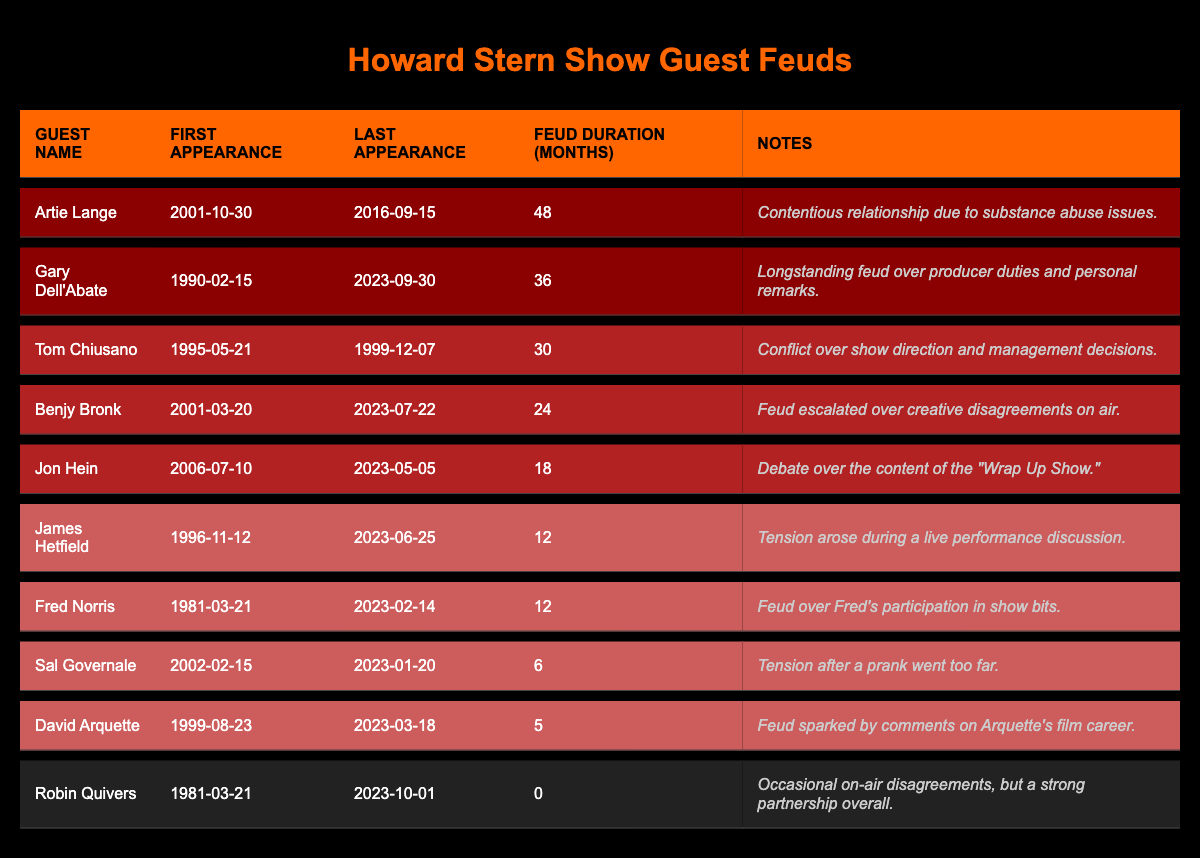What is the feud duration for Artie Lange? The table lists the feud duration of Artie Lange as 48 months.
Answer: 48 months Who had the longest feud duration on the table? By comparing the feud durations, Artie Lange has the longest feud duration of 48 months.
Answer: Artie Lange How many months did Gary Dell'Abate feud last? The table states that Gary Dell'Abate’s feud duration is 36 months.
Answer: 36 months Which guest had a feud duration of 0 months? The table indicates that Robin Quivers has a feud duration of 0 months, signifying no significant feud.
Answer: Robin Quivers Which two guests had feud durations of 12 months? The table shows that James Hetfield and Fred Norris both have a feud duration of 12 months each.
Answer: James Hetfield and Fred Norris What is the average feud duration of guests with medium feud durations on the table? The medium feud durations for Benjy Bronk (24), Jon Hein (18), and Tom Chiusano (30) can be averaged: (24 + 18 + 30) / 3 = 24.
Answer: 24 months Is it true that David Arquette had a longer feud than Sal Governale? David Arquette had a feud duration of 5 months and Sal Governale for 6 months, so the statement is false.
Answer: No Which guest has the shortest feud duration and what is it? The table shows David Arquette having the shortest feud duration of 5 months.
Answer: 5 months What is the total feud duration for all guests listed? Adding all the feud durations: 48 + 36 + 24 + 12 + 30 + 18 + 12 + 6 + 5 + 0 = 191 months.
Answer: 191 months How many guests had feuds lasting longer than 24 months? The guests with feuds longer than 24 months are Artie Lange (48), Gary Dell'Abate (36), and Benjy Bronk (24). That makes three guests.
Answer: 3 guests 